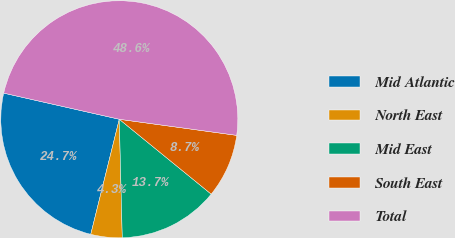Convert chart. <chart><loc_0><loc_0><loc_500><loc_500><pie_chart><fcel>Mid Atlantic<fcel>North East<fcel>Mid East<fcel>South East<fcel>Total<nl><fcel>24.67%<fcel>4.27%<fcel>13.72%<fcel>8.71%<fcel>48.63%<nl></chart> 